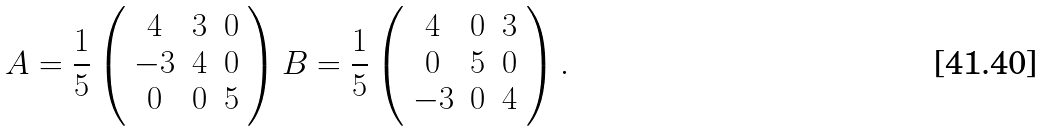<formula> <loc_0><loc_0><loc_500><loc_500>A = \frac { 1 } { 5 } \left ( \begin{array} { c c c } 4 & 3 & 0 \\ - 3 & 4 & 0 \\ 0 & 0 & 5 \\ \end{array} \right ) B = \frac { 1 } { 5 } \left ( \begin{array} { c c c } 4 & 0 & 3 \\ 0 & 5 & 0 \\ - 3 & 0 & 4 \\ \end{array} \right ) .</formula> 